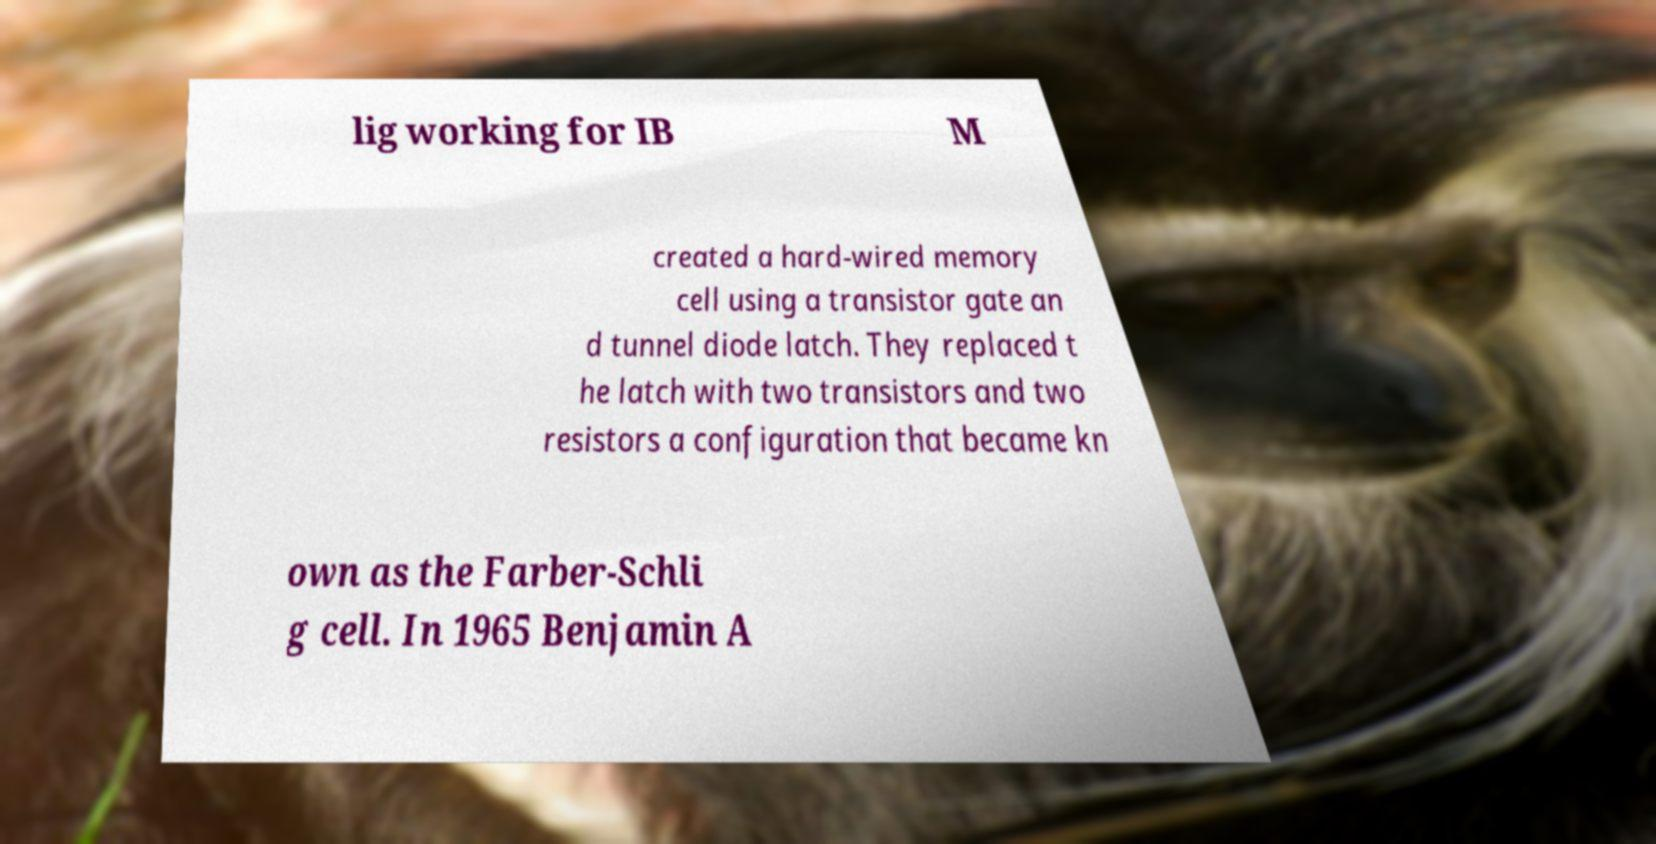Please read and relay the text visible in this image. What does it say? lig working for IB M created a hard-wired memory cell using a transistor gate an d tunnel diode latch. They replaced t he latch with two transistors and two resistors a configuration that became kn own as the Farber-Schli g cell. In 1965 Benjamin A 